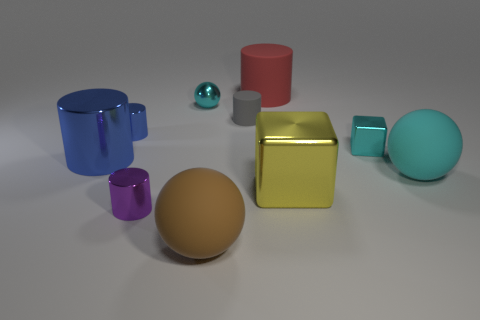Subtract all yellow cylinders. Subtract all red blocks. How many cylinders are left? 5 Subtract all blocks. How many objects are left? 8 Subtract all matte spheres. Subtract all large blue shiny cylinders. How many objects are left? 7 Add 8 tiny rubber objects. How many tiny rubber objects are left? 9 Add 8 small cyan shiny cubes. How many small cyan shiny cubes exist? 9 Subtract 0 brown cylinders. How many objects are left? 10 